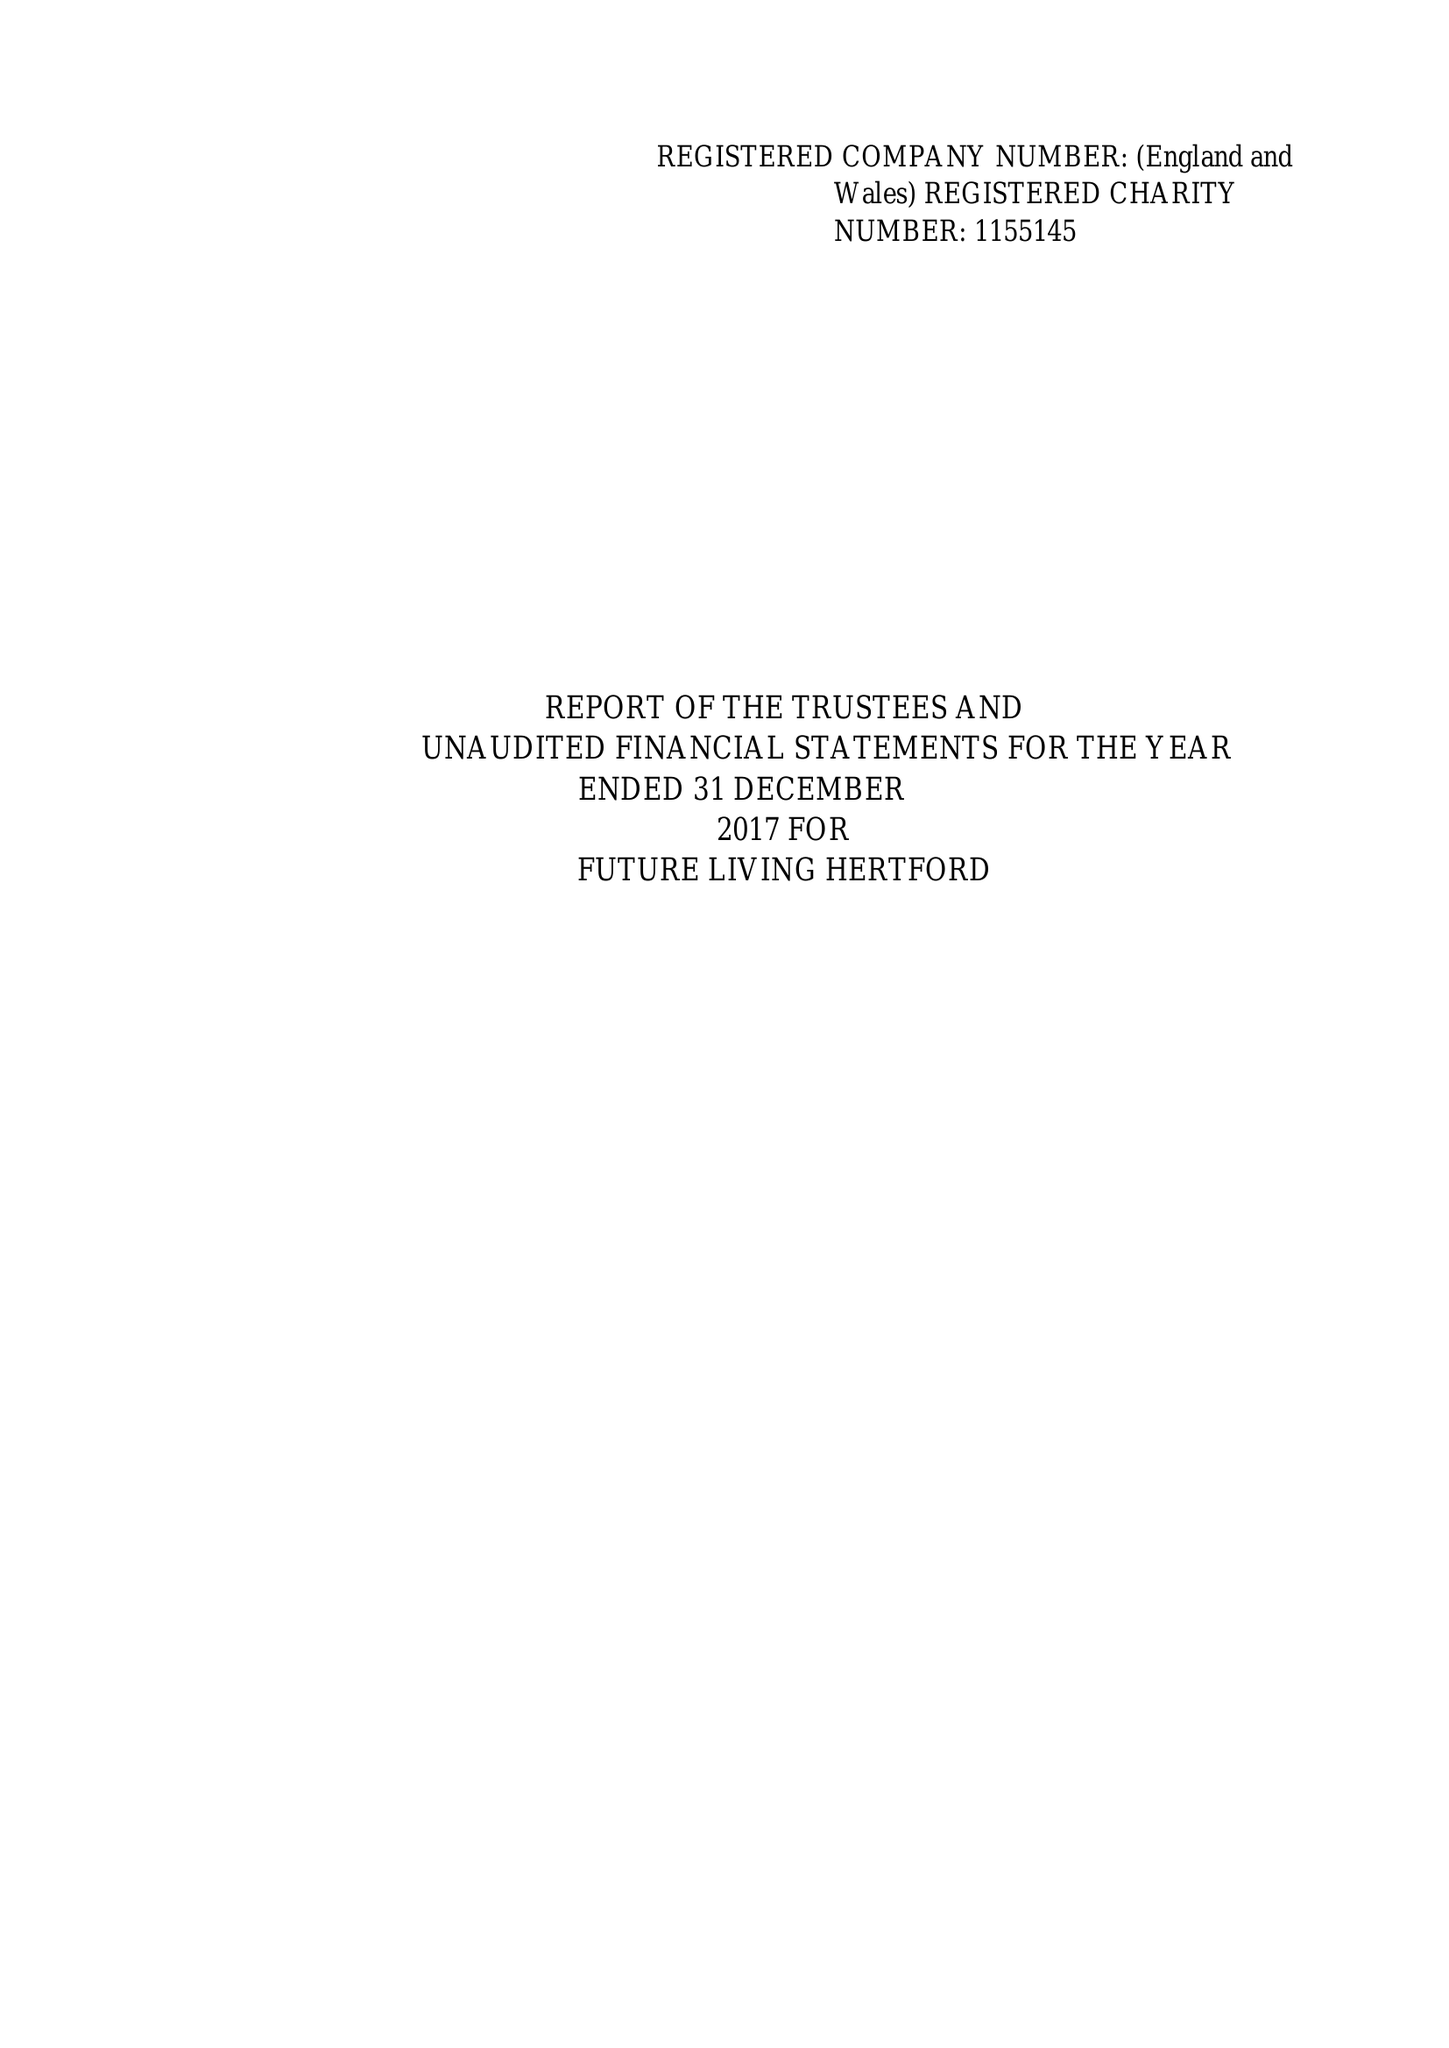What is the value for the charity_name?
Answer the question using a single word or phrase. Future Living Hertford 